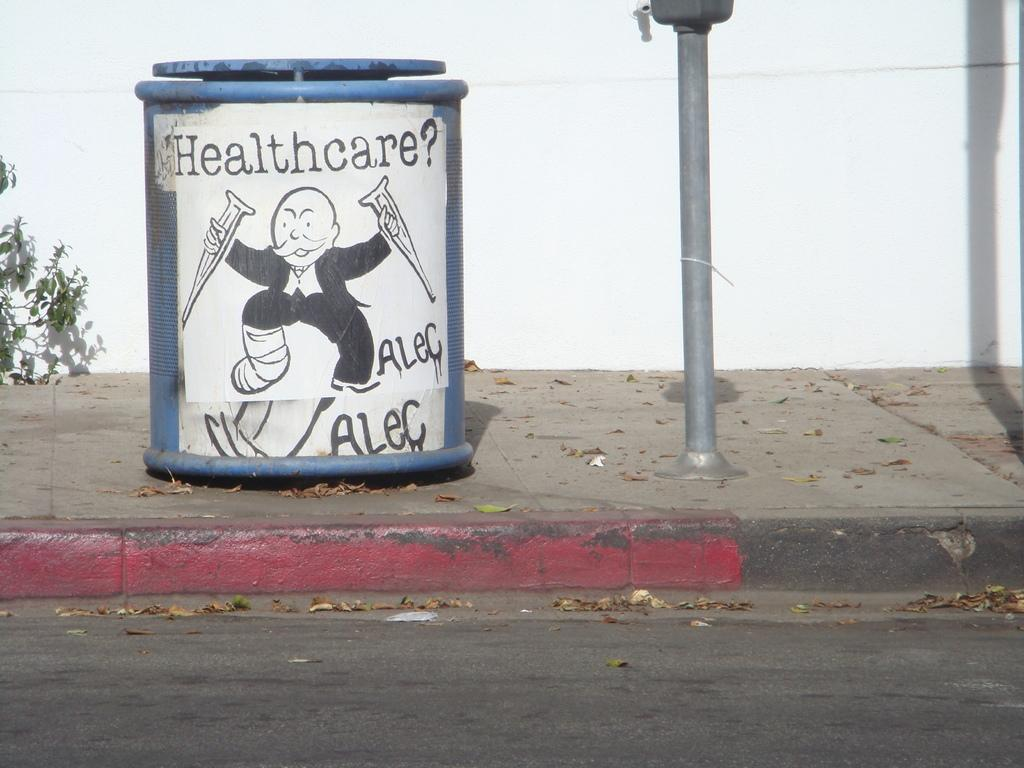<image>
Provide a brief description of the given image. A sign on a trashcan that says 'healthcare? alec alec' on it 